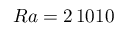Convert formula to latex. <formula><loc_0><loc_0><loc_500><loc_500>R a = 2 \, 1 0 1 0</formula> 